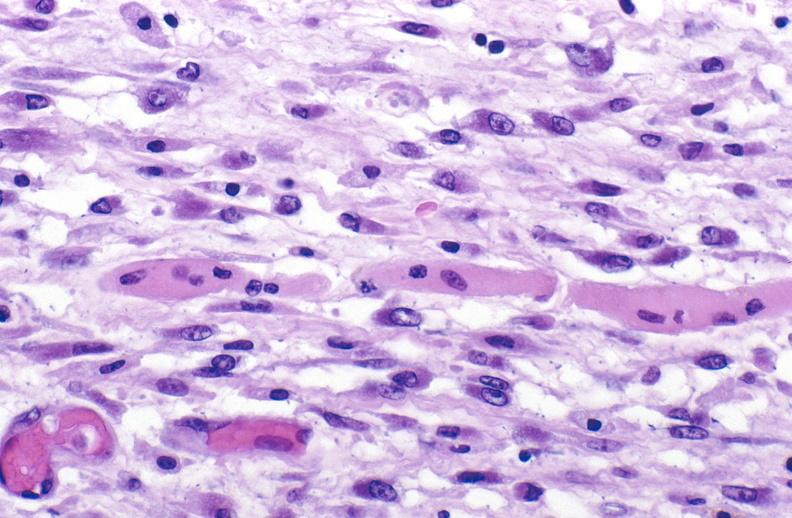does this protocol show tracheotomy site, granulation tissue?
Answer the question using a single word or phrase. No 